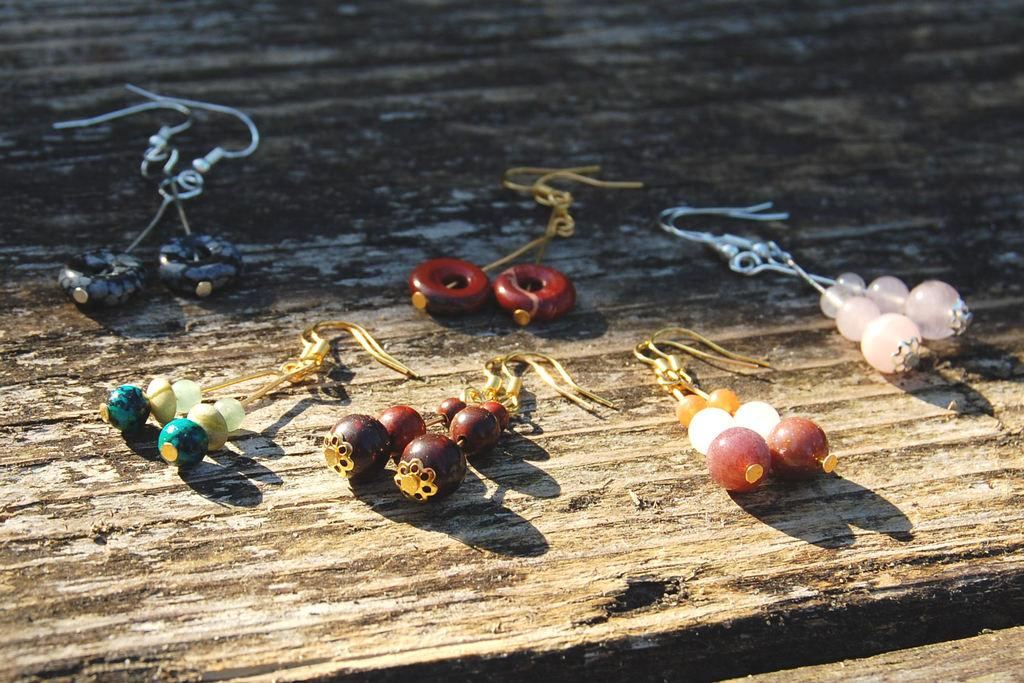What type of objects can be seen in the image? There are beads and rings in the image. How are the beads and rings connected? The beads and rings are attached to threads. What surface can be seen in the image? There is a wooden surface in the image. How many apples are being washed on the wooden surface in the image? There are no apples present in the image, and therefore no washing activity can be observed. 